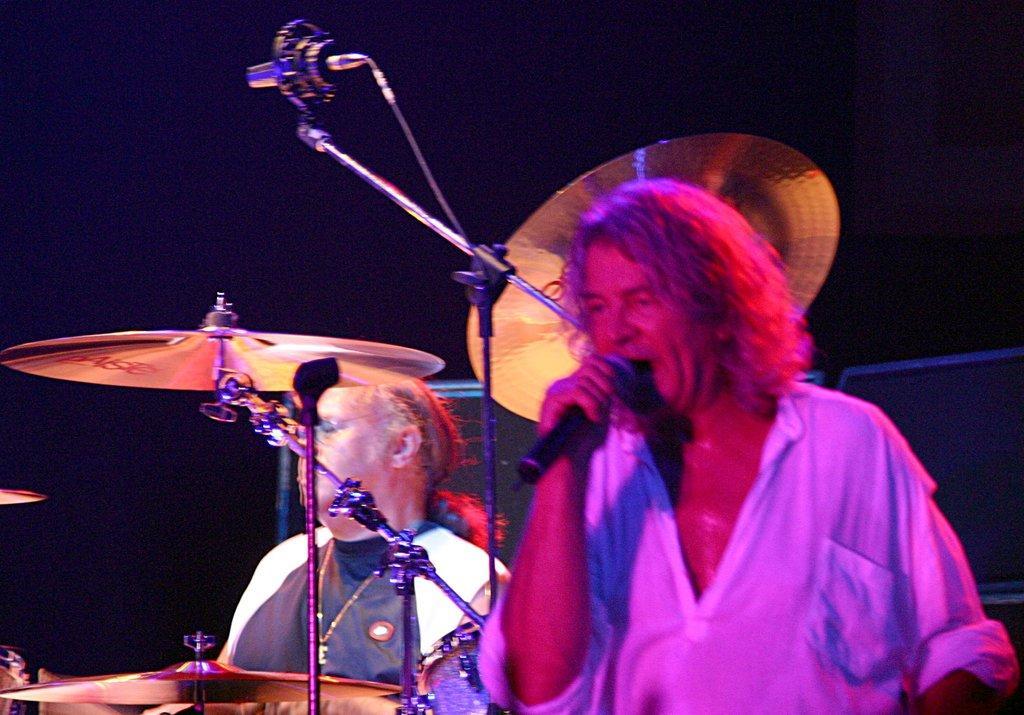In one or two sentences, can you explain what this image depicts? In this image we can see there are persons holding a mic. And there are musical instruments. And at the back the object looks like a speaker. 